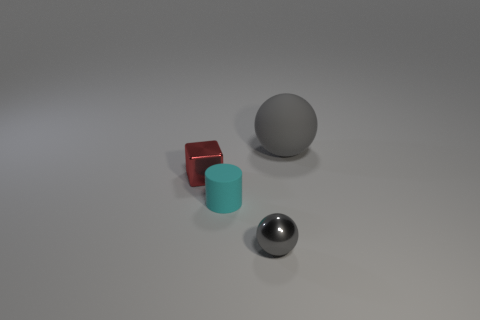How many gray balls must be subtracted to get 1 gray balls? 1 Add 2 small yellow matte objects. How many objects exist? 6 Subtract 1 gray spheres. How many objects are left? 3 Subtract all cylinders. How many objects are left? 3 Subtract all tiny gray cylinders. Subtract all small cyan rubber cylinders. How many objects are left? 3 Add 3 tiny red metal cubes. How many tiny red metal cubes are left? 4 Add 2 small blocks. How many small blocks exist? 3 